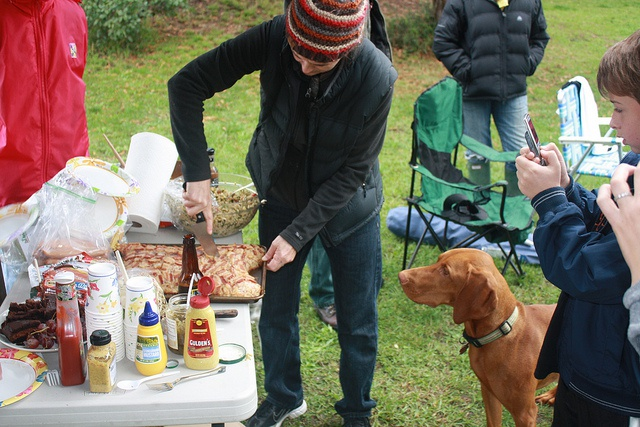Describe the objects in this image and their specific colors. I can see dining table in maroon, lightgray, darkgray, tan, and gray tones, people in maroon, black, gray, blue, and darkblue tones, people in maroon, black, navy, and gray tones, people in maroon, brown, and salmon tones, and dog in maroon, brown, and salmon tones in this image. 